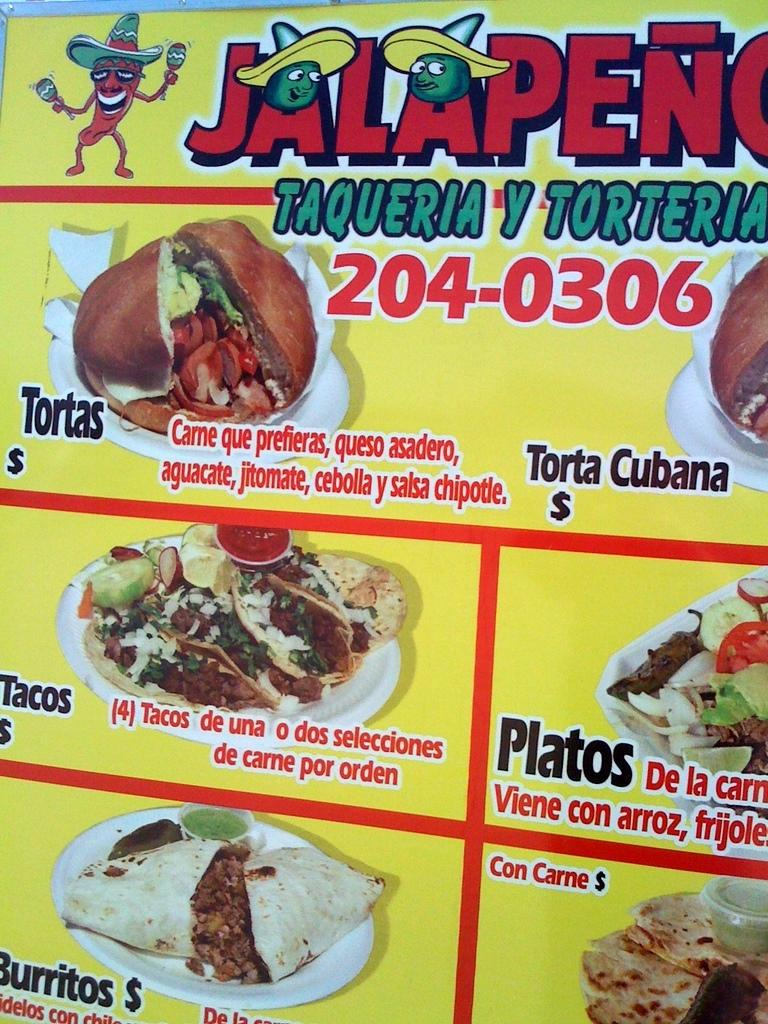What is the main subject in the center of the image? There is a poster in the center of the image. What can be seen on the poster? The poster contains images of food items. Is there any text on the poster? Yes, there is text on the poster. How many balloons are tied to the poster in the image? There are no balloons present in the image. What causes the poster to rise in the air in the image? The poster is not rising in the air in the image; it is stationary on a surface. 